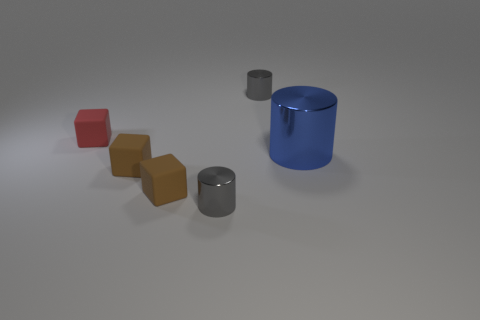The big object on the right side of the tiny gray cylinder in front of the object behind the small red matte thing is what color? The large object situated to the right of the small gray cylinder, which is in turn located in front of an object situated behind a small red block with a matte surface, is blue in color. This blue object appears to be a cylinder with a reflective surface, suggesting it may be made of a material such as polished metal or plastic. 